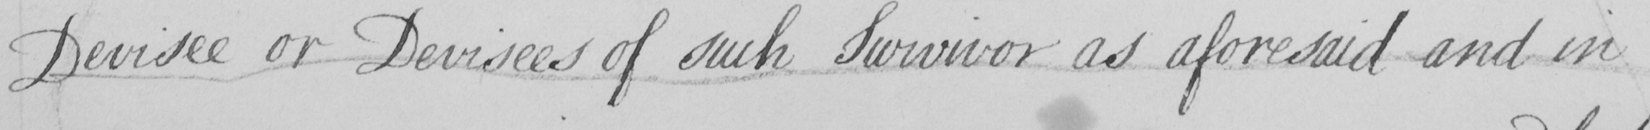Transcribe the text shown in this historical manuscript line. Devisee or Devisees of such Survivor as aforesaid and in 